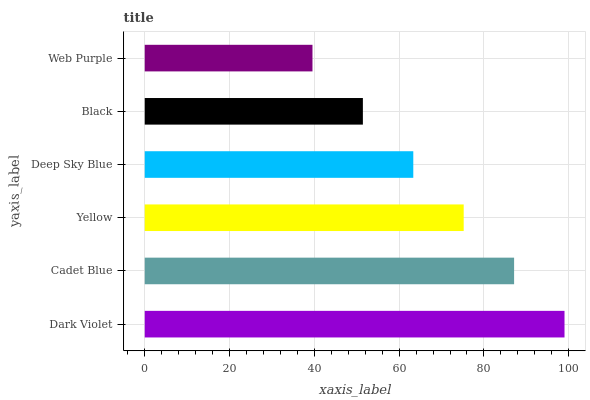Is Web Purple the minimum?
Answer yes or no. Yes. Is Dark Violet the maximum?
Answer yes or no. Yes. Is Cadet Blue the minimum?
Answer yes or no. No. Is Cadet Blue the maximum?
Answer yes or no. No. Is Dark Violet greater than Cadet Blue?
Answer yes or no. Yes. Is Cadet Blue less than Dark Violet?
Answer yes or no. Yes. Is Cadet Blue greater than Dark Violet?
Answer yes or no. No. Is Dark Violet less than Cadet Blue?
Answer yes or no. No. Is Yellow the high median?
Answer yes or no. Yes. Is Deep Sky Blue the low median?
Answer yes or no. Yes. Is Cadet Blue the high median?
Answer yes or no. No. Is Web Purple the low median?
Answer yes or no. No. 